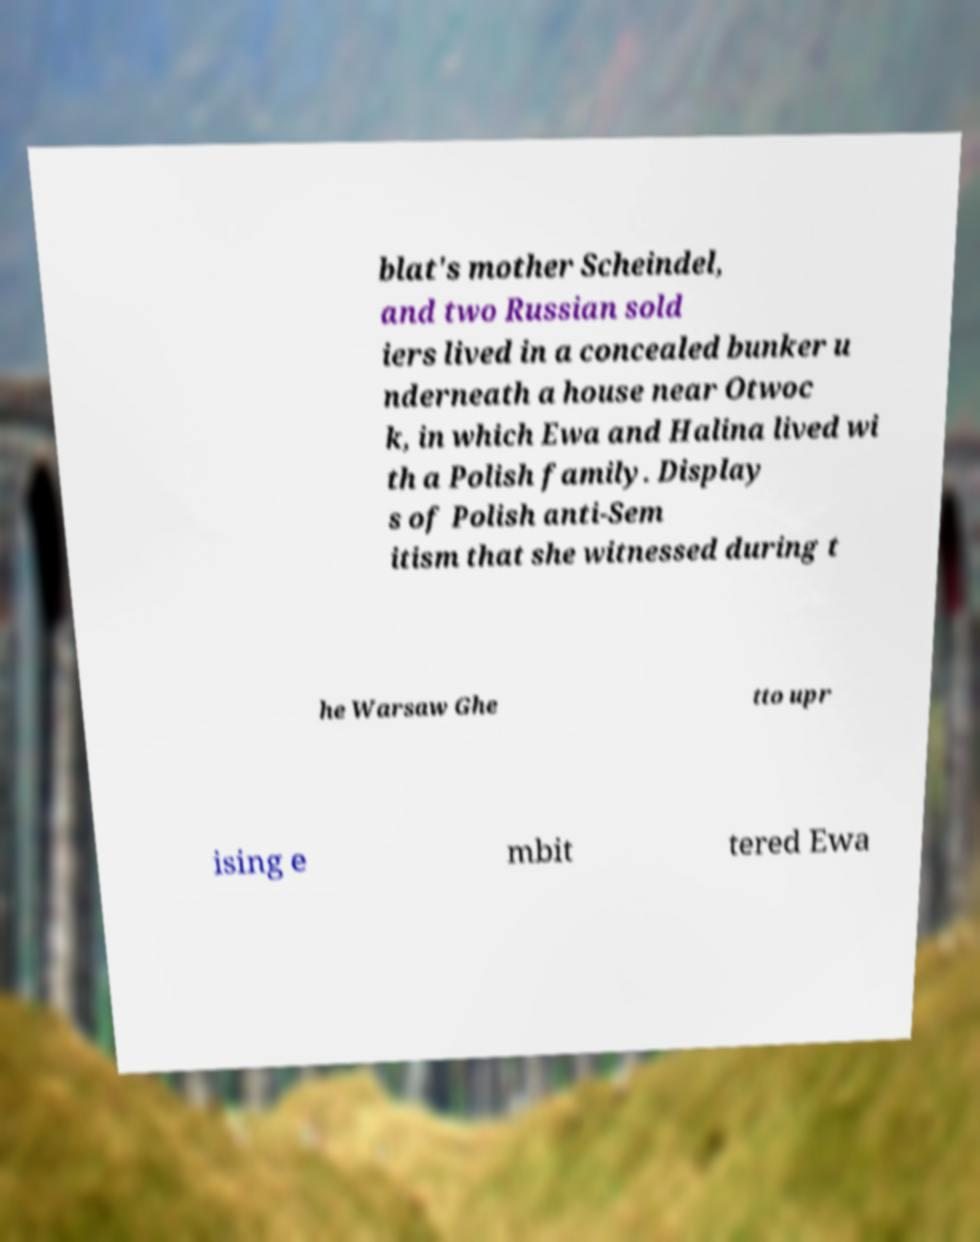I need the written content from this picture converted into text. Can you do that? blat's mother Scheindel, and two Russian sold iers lived in a concealed bunker u nderneath a house near Otwoc k, in which Ewa and Halina lived wi th a Polish family. Display s of Polish anti-Sem itism that she witnessed during t he Warsaw Ghe tto upr ising e mbit tered Ewa 